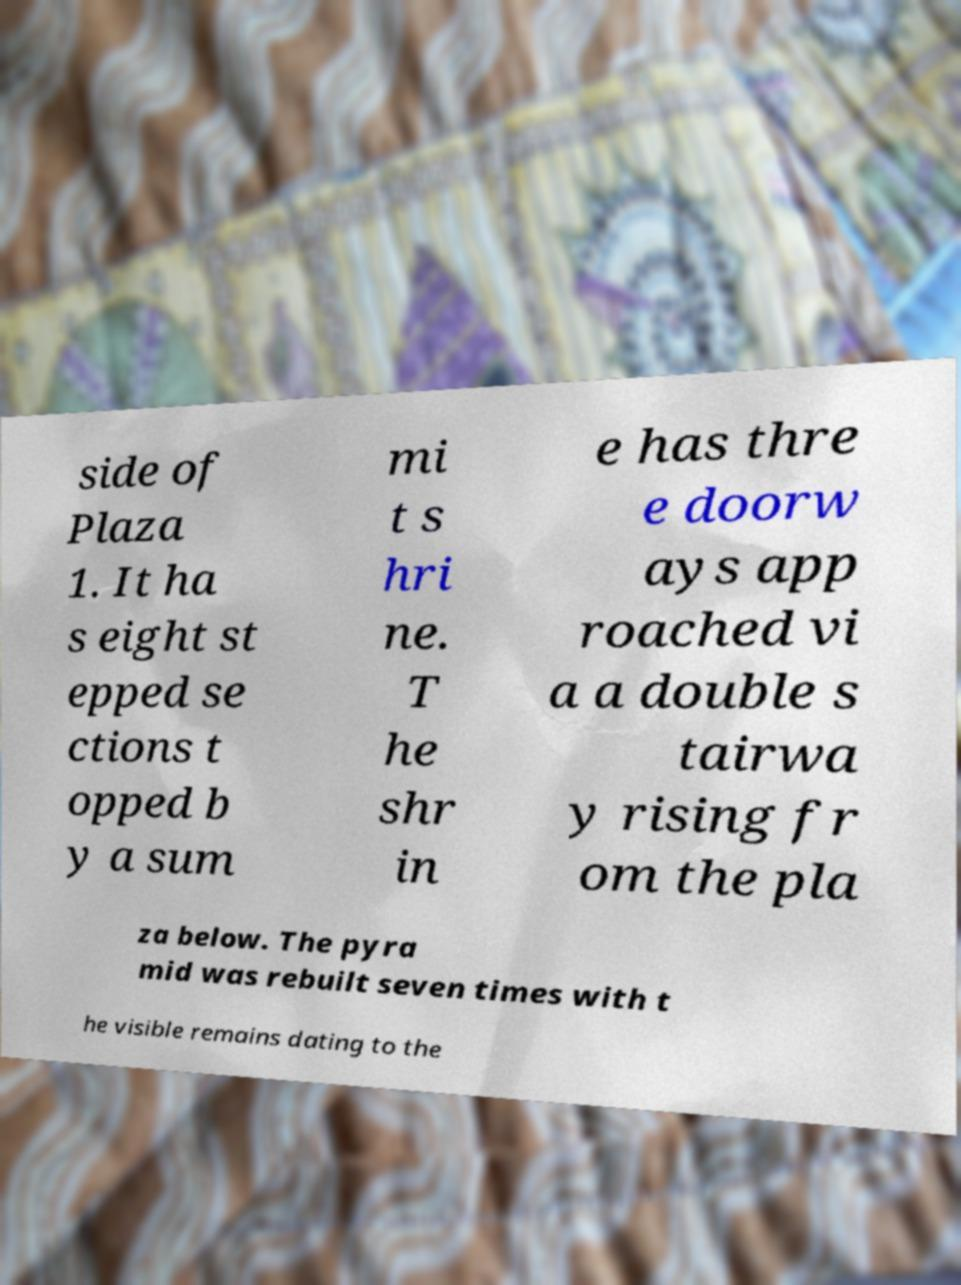What messages or text are displayed in this image? I need them in a readable, typed format. side of Plaza 1. It ha s eight st epped se ctions t opped b y a sum mi t s hri ne. T he shr in e has thre e doorw ays app roached vi a a double s tairwa y rising fr om the pla za below. The pyra mid was rebuilt seven times with t he visible remains dating to the 